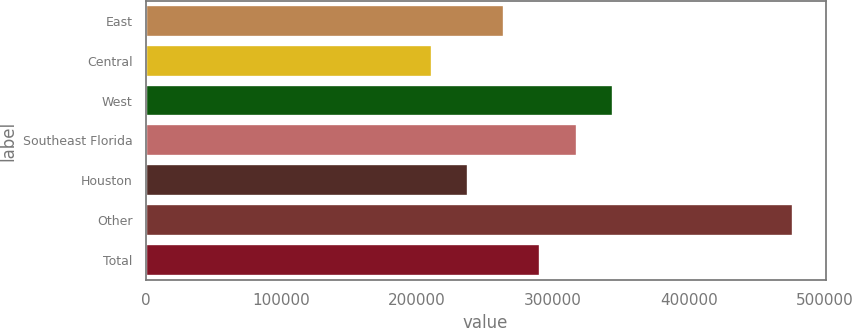<chart> <loc_0><loc_0><loc_500><loc_500><bar_chart><fcel>East<fcel>Central<fcel>West<fcel>Southeast Florida<fcel>Houston<fcel>Other<fcel>Total<nl><fcel>264200<fcel>211000<fcel>344000<fcel>317400<fcel>237600<fcel>477000<fcel>290800<nl></chart> 